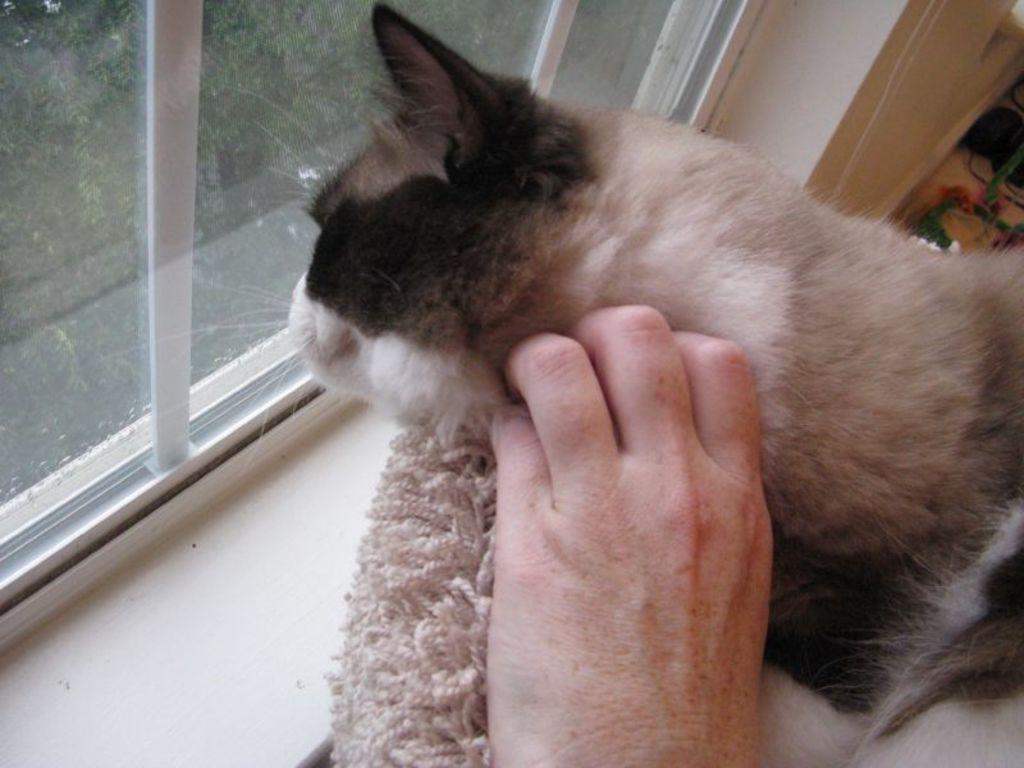Can you describe this image briefly? In this picture I can see a cat and a human hand and I can see a glass window and I can see a cloth. 